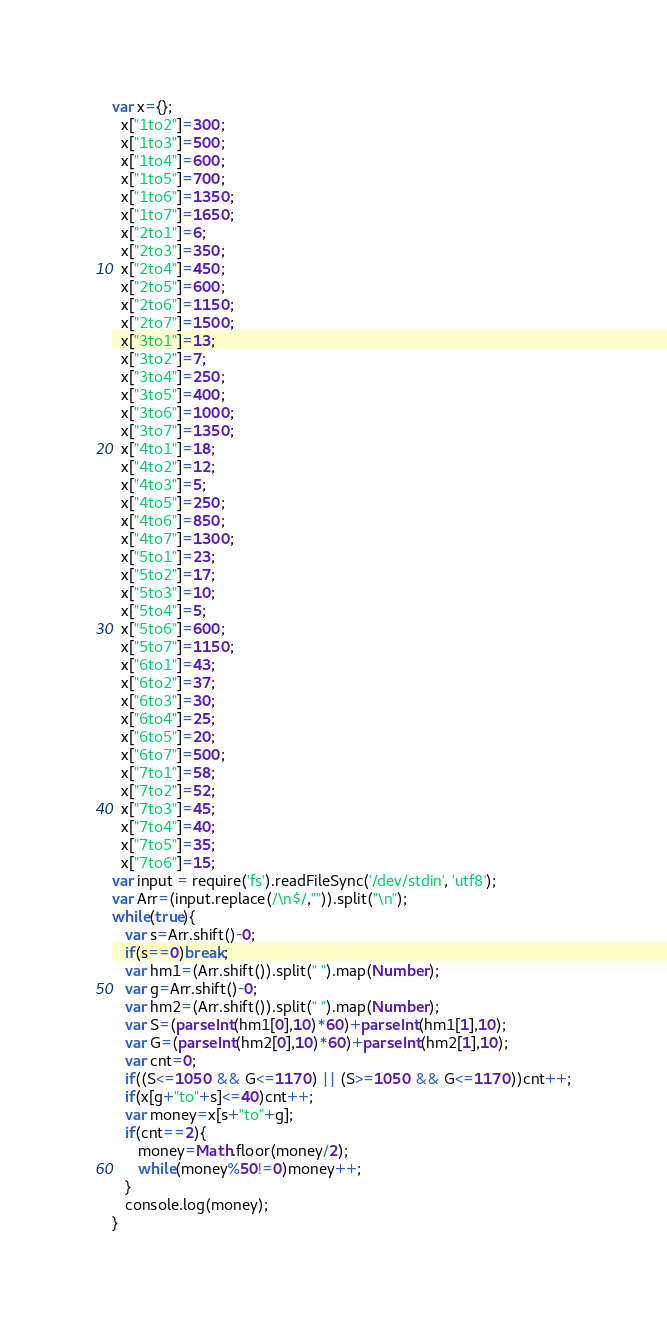Convert code to text. <code><loc_0><loc_0><loc_500><loc_500><_JavaScript_>var x={};
  x["1to2"]=300;
  x["1to3"]=500;
  x["1to4"]=600;
  x["1to5"]=700;
  x["1to6"]=1350;
  x["1to7"]=1650;
  x["2to1"]=6;
  x["2to3"]=350;
  x["2to4"]=450;
  x["2to5"]=600;
  x["2to6"]=1150;  
  x["2to7"]=1500;
  x["3to1"]=13;
  x["3to2"]=7;
  x["3to4"]=250;
  x["3to5"]=400;
  x["3to6"]=1000;
  x["3to7"]=1350;
  x["4to1"]=18;
  x["4to2"]=12;
  x["4to3"]=5;
  x["4to5"]=250;
  x["4to6"]=850;
  x["4to7"]=1300;
  x["5to1"]=23;
  x["5to2"]=17;
  x["5to3"]=10;
  x["5to4"]=5;
  x["5to6"]=600;
  x["5to7"]=1150;
  x["6to1"]=43;
  x["6to2"]=37;
  x["6to3"]=30;
  x["6to4"]=25;
  x["6to5"]=20;
  x["6to7"]=500;
  x["7to1"]=58;
  x["7to2"]=52;
  x["7to3"]=45;
  x["7to4"]=40;
  x["7to5"]=35;
  x["7to6"]=15;
var input = require('fs').readFileSync('/dev/stdin', 'utf8');
var Arr=(input.replace(/\n$/,"")).split("\n");
while(true){
   var s=Arr.shift()-0;
   if(s==0)break;
   var hm1=(Arr.shift()).split(" ").map(Number);
   var g=Arr.shift()-0;
   var hm2=(Arr.shift()).split(" ").map(Number);
   var S=(parseInt(hm1[0],10)*60)+parseInt(hm1[1],10);
   var G=(parseInt(hm2[0],10)*60)+parseInt(hm2[1],10);
   var cnt=0;
   if((S<=1050 && G<=1170) || (S>=1050 && G<=1170))cnt++;
   if(x[g+"to"+s]<=40)cnt++;
   var money=x[s+"to"+g];
   if(cnt==2){
      money=Math.floor(money/2);
      while(money%50!=0)money++;
   }
   console.log(money);
}</code> 